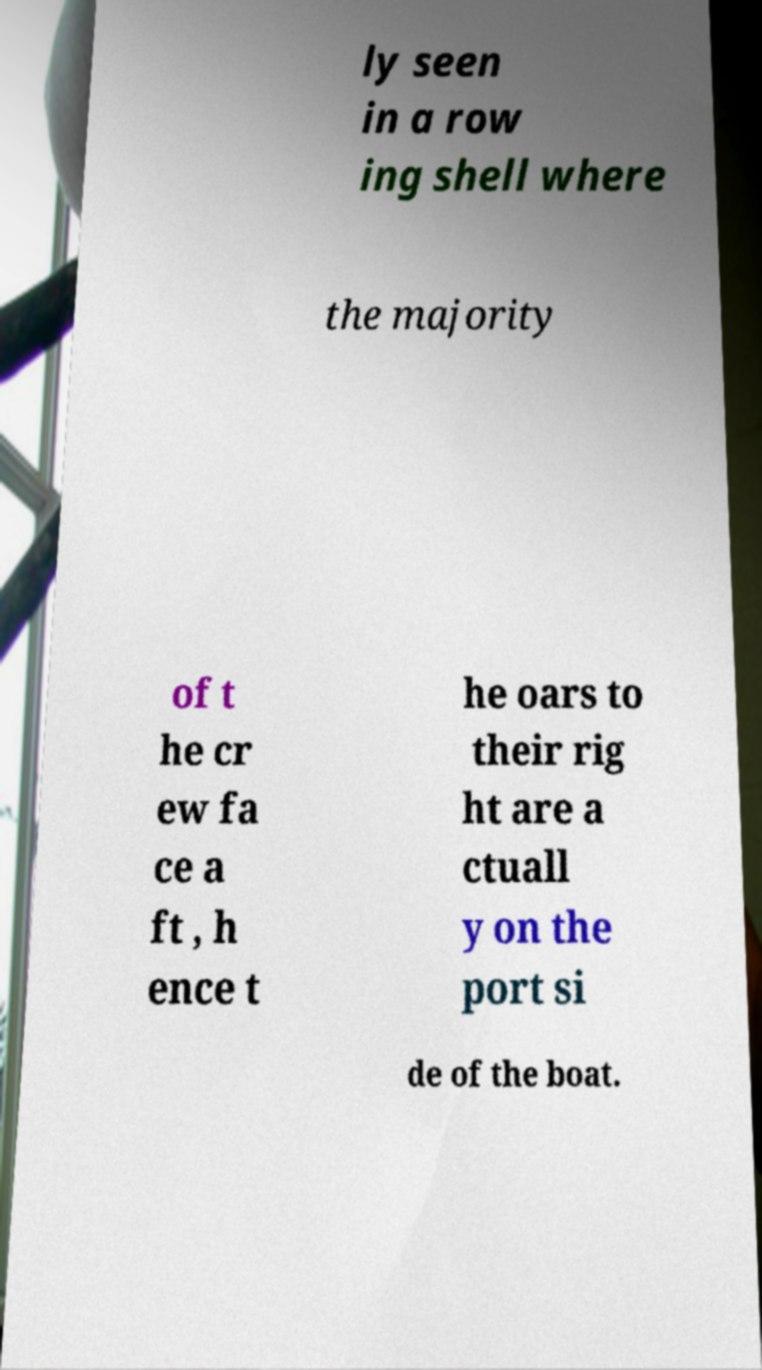What messages or text are displayed in this image? I need them in a readable, typed format. ly seen in a row ing shell where the majority of t he cr ew fa ce a ft , h ence t he oars to their rig ht are a ctuall y on the port si de of the boat. 